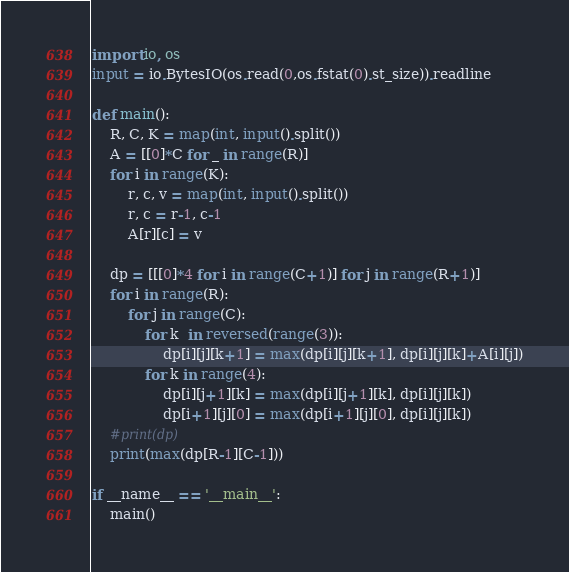<code> <loc_0><loc_0><loc_500><loc_500><_Python_>import io, os
input = io.BytesIO(os.read(0,os.fstat(0).st_size)).readline

def main():
    R, C, K = map(int, input().split())
    A = [[0]*C for _ in range(R)]
    for i in range(K):
        r, c, v = map(int, input().split())
        r, c = r-1, c-1
        A[r][c] = v

    dp = [[[0]*4 for i in range(C+1)] for j in range(R+1)]
    for i in range(R):
        for j in range(C):
            for k  in reversed(range(3)):
                dp[i][j][k+1] = max(dp[i][j][k+1], dp[i][j][k]+A[i][j])
            for k in range(4):
                dp[i][j+1][k] = max(dp[i][j+1][k], dp[i][j][k])
                dp[i+1][j][0] = max(dp[i+1][j][0], dp[i][j][k])
    #print(dp)
    print(max(dp[R-1][C-1]))

if __name__ == '__main__':
    main()
</code> 